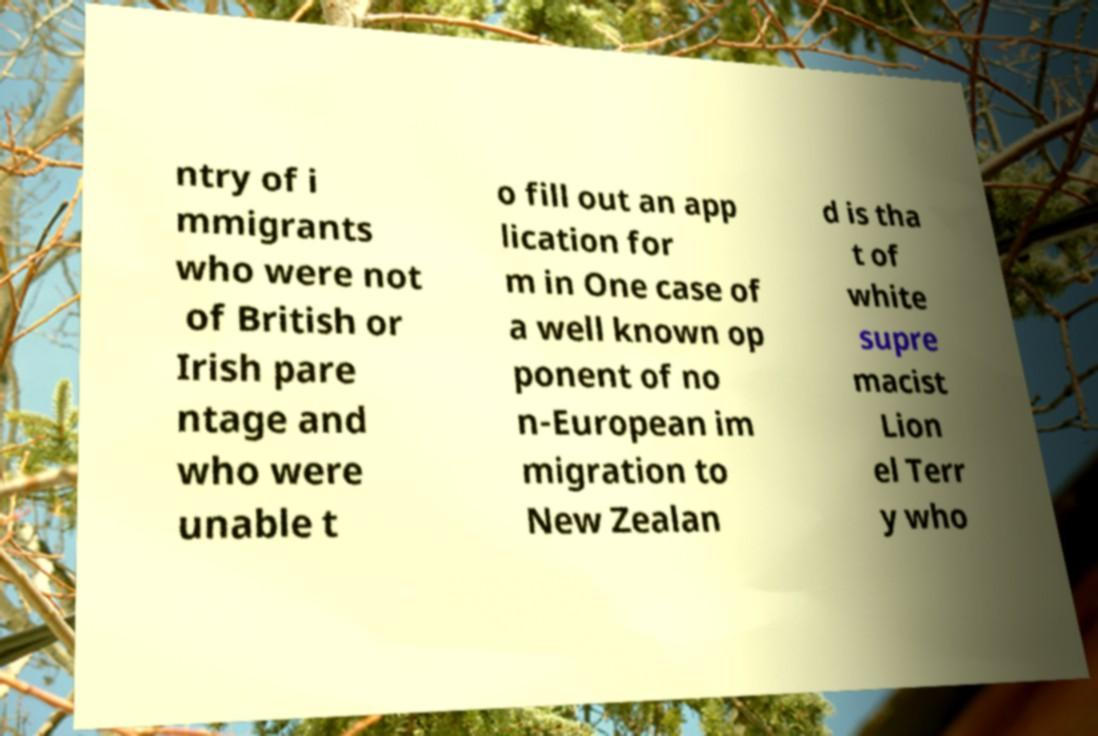Please read and relay the text visible in this image. What does it say? ntry of i mmigrants who were not of British or Irish pare ntage and who were unable t o fill out an app lication for m in One case of a well known op ponent of no n-European im migration to New Zealan d is tha t of white supre macist Lion el Terr y who 